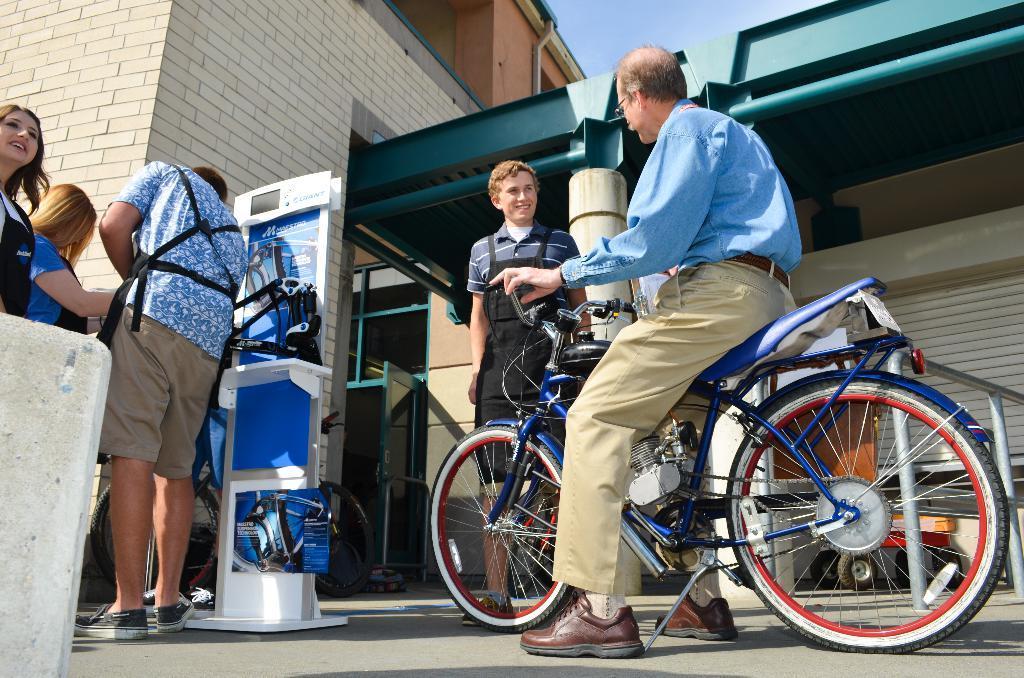Can you describe this image briefly? In this image i can see a person wearing a blue shirt, grey pant and shows setting on bicycle, I can see few other persons standing in front of him. in the background I can see the building and the sky. 